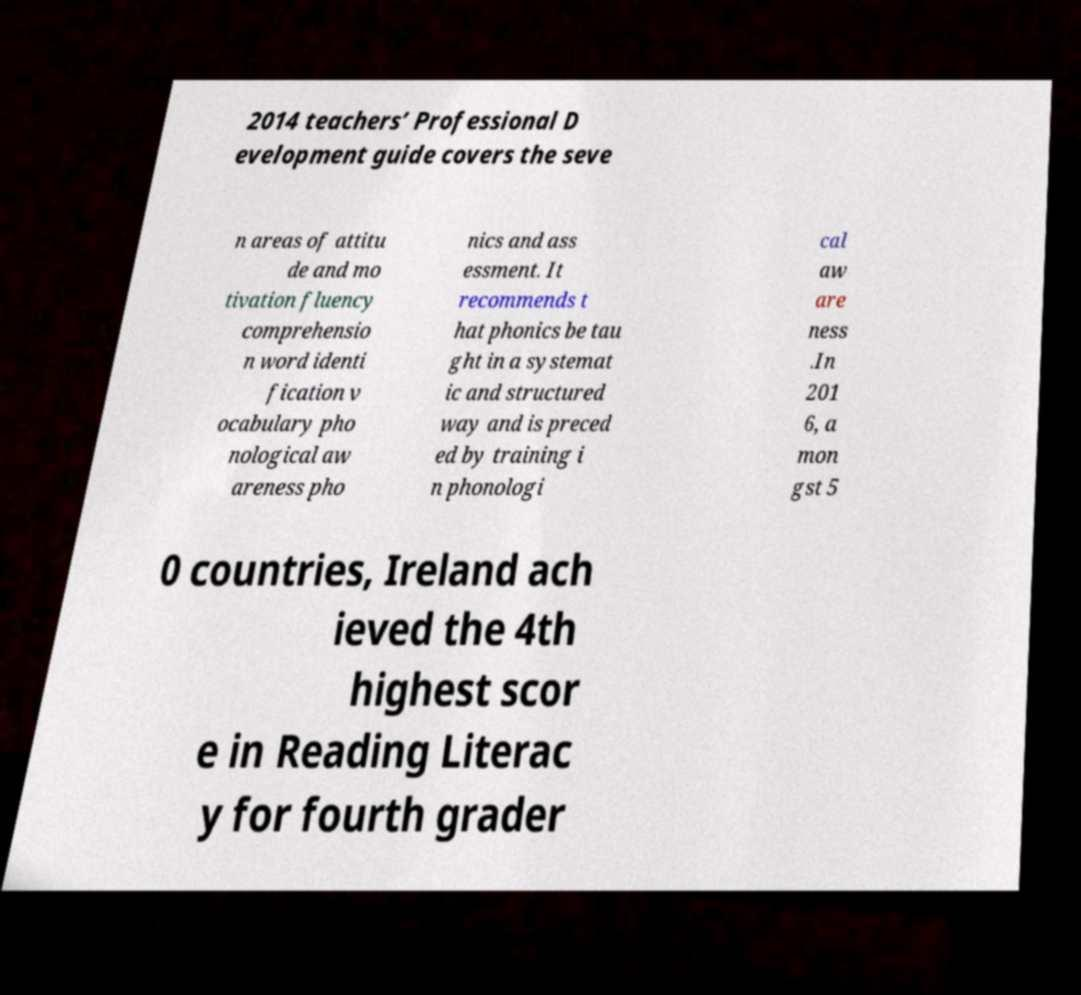There's text embedded in this image that I need extracted. Can you transcribe it verbatim? 2014 teachers’ Professional D evelopment guide covers the seve n areas of attitu de and mo tivation fluency comprehensio n word identi fication v ocabulary pho nological aw areness pho nics and ass essment. It recommends t hat phonics be tau ght in a systemat ic and structured way and is preced ed by training i n phonologi cal aw are ness .In 201 6, a mon gst 5 0 countries, Ireland ach ieved the 4th highest scor e in Reading Literac y for fourth grader 